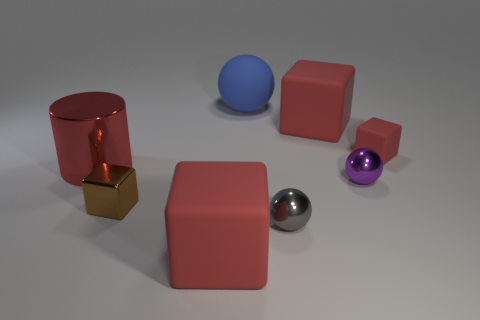Subtract all red cubes. How many were subtracted if there are1red cubes left? 2 Subtract all red cubes. How many cubes are left? 1 Subtract all green cylinders. How many red cubes are left? 3 Subtract all brown blocks. How many blocks are left? 3 Subtract 1 spheres. How many spheres are left? 2 Add 2 large cyan spheres. How many objects exist? 10 Subtract all gray cubes. Subtract all gray spheres. How many cubes are left? 4 Subtract all cylinders. How many objects are left? 7 Subtract all gray metallic things. Subtract all big blue spheres. How many objects are left? 6 Add 3 red rubber objects. How many red rubber objects are left? 6 